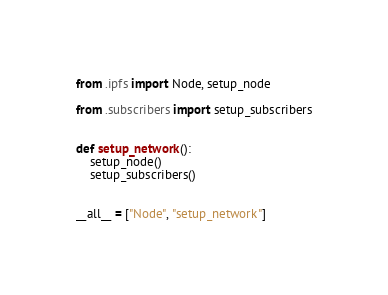<code> <loc_0><loc_0><loc_500><loc_500><_Python_>from .ipfs import Node, setup_node

from .subscribers import setup_subscribers


def setup_network():
    setup_node()
    setup_subscribers()


__all__ = ["Node", "setup_network"]
</code> 